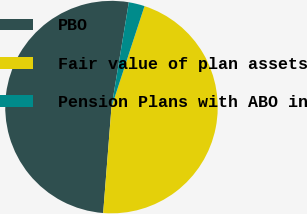<chart> <loc_0><loc_0><loc_500><loc_500><pie_chart><fcel>PBO<fcel>Fair value of plan assets<fcel>Pension Plans with ABO in<nl><fcel>51.36%<fcel>46.21%<fcel>2.42%<nl></chart> 